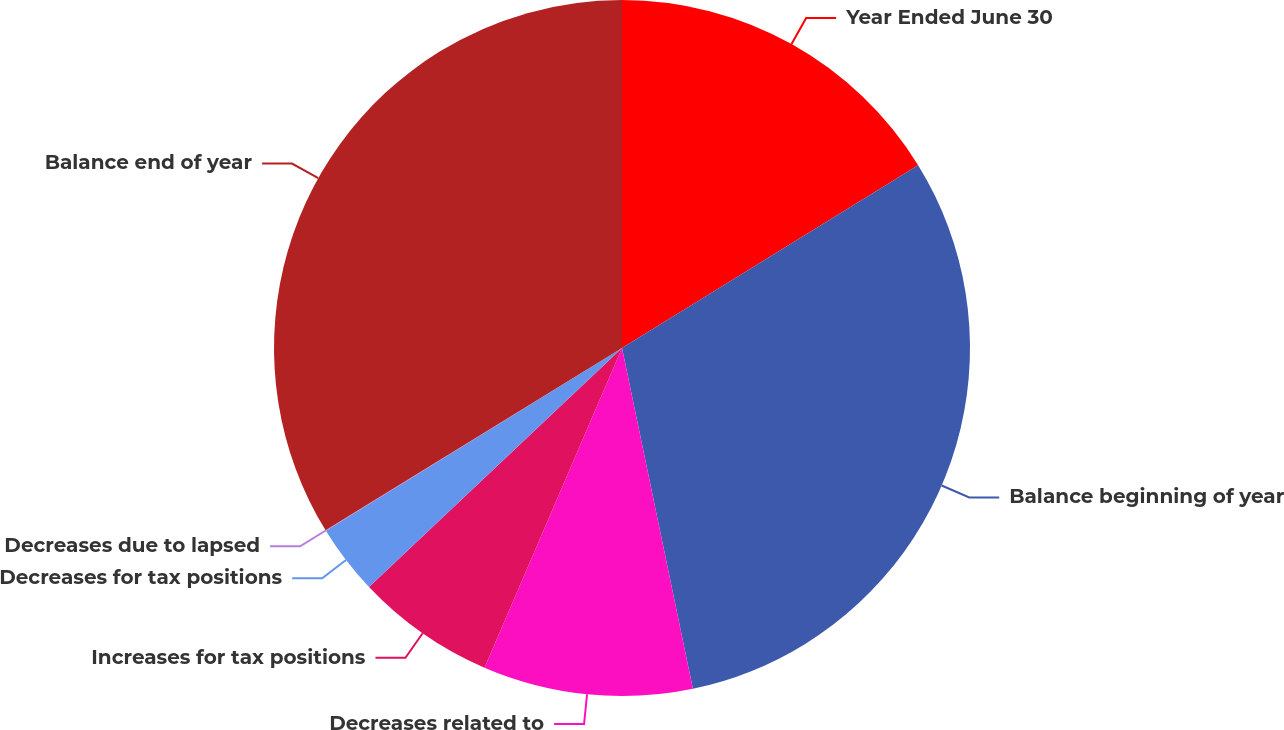Convert chart. <chart><loc_0><loc_0><loc_500><loc_500><pie_chart><fcel>Year Ended June 30<fcel>Balance beginning of year<fcel>Decreases related to<fcel>Increases for tax positions<fcel>Decreases for tax positions<fcel>Decreases due to lapsed<fcel>Balance end of year<nl><fcel>16.2%<fcel>30.54%<fcel>9.73%<fcel>6.49%<fcel>3.25%<fcel>0.02%<fcel>33.78%<nl></chart> 